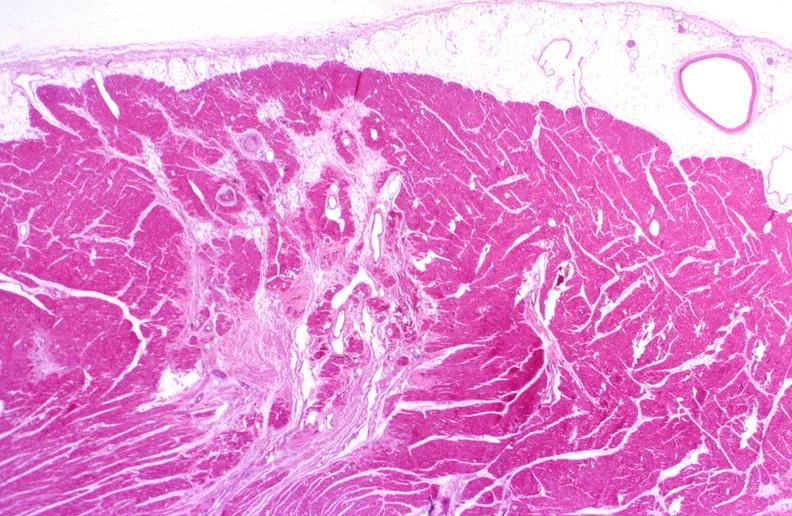s cardiovascular present?
Answer the question using a single word or phrase. Yes 